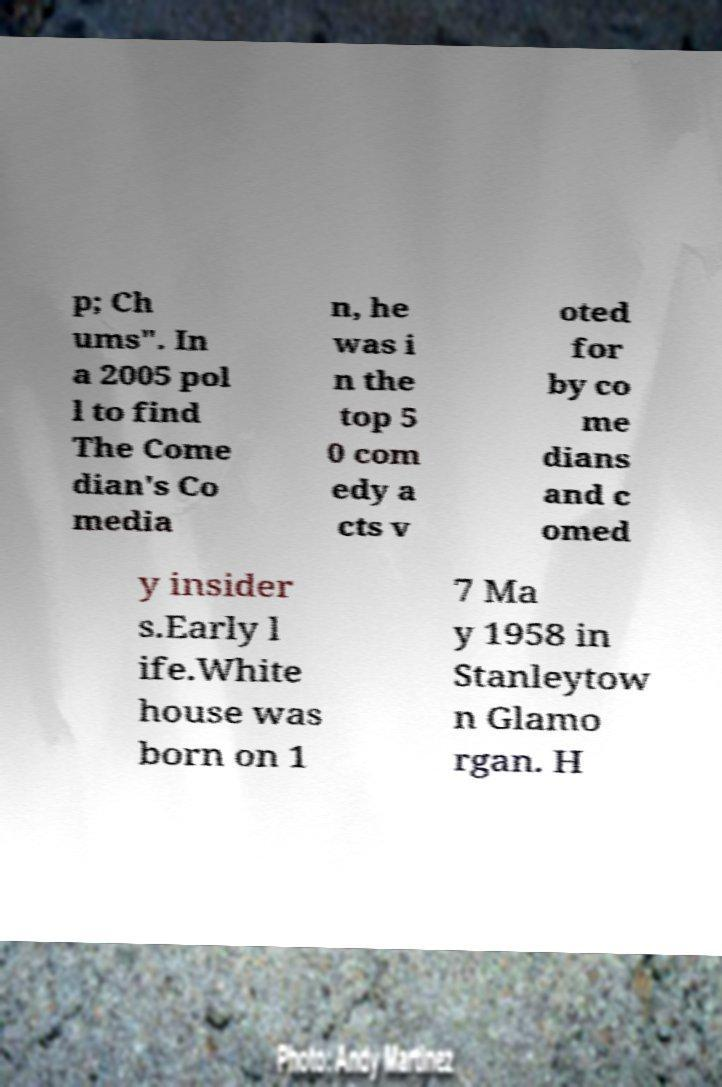I need the written content from this picture converted into text. Can you do that? p; Ch ums". In a 2005 pol l to find The Come dian's Co media n, he was i n the top 5 0 com edy a cts v oted for by co me dians and c omed y insider s.Early l ife.White house was born on 1 7 Ma y 1958 in Stanleytow n Glamo rgan. H 